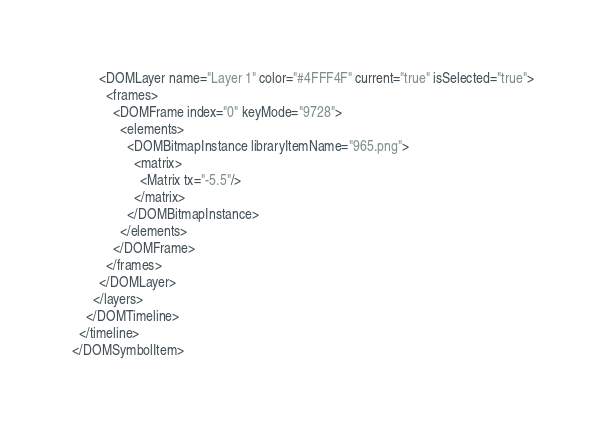Convert code to text. <code><loc_0><loc_0><loc_500><loc_500><_XML_>        <DOMLayer name="Layer 1" color="#4FFF4F" current="true" isSelected="true">
          <frames>
            <DOMFrame index="0" keyMode="9728">
              <elements>
                <DOMBitmapInstance libraryItemName="965.png">
                  <matrix>
                    <Matrix tx="-5.5"/>
                  </matrix>
                </DOMBitmapInstance>
              </elements>
            </DOMFrame>
          </frames>
        </DOMLayer>
      </layers>
    </DOMTimeline>
  </timeline>
</DOMSymbolItem></code> 